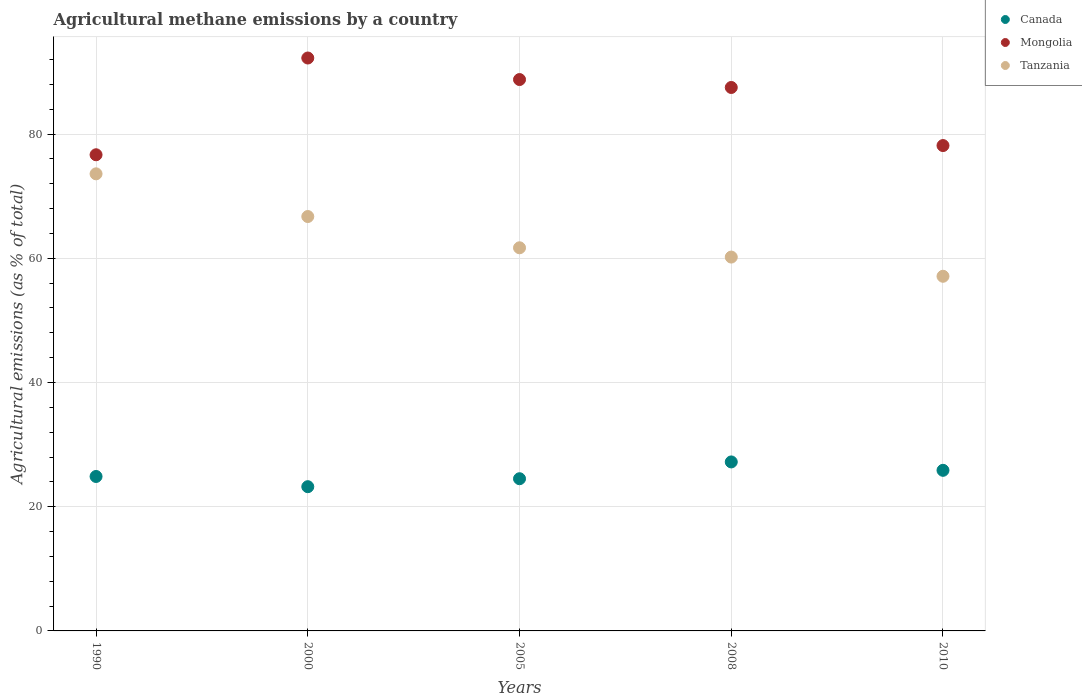What is the amount of agricultural methane emitted in Mongolia in 1990?
Give a very brief answer. 76.66. Across all years, what is the maximum amount of agricultural methane emitted in Canada?
Offer a very short reply. 27.21. Across all years, what is the minimum amount of agricultural methane emitted in Canada?
Provide a short and direct response. 23.22. What is the total amount of agricultural methane emitted in Mongolia in the graph?
Ensure brevity in your answer.  423.3. What is the difference between the amount of agricultural methane emitted in Tanzania in 1990 and that in 2005?
Your answer should be compact. 11.91. What is the difference between the amount of agricultural methane emitted in Tanzania in 1990 and the amount of agricultural methane emitted in Canada in 2010?
Your answer should be very brief. 47.73. What is the average amount of agricultural methane emitted in Mongolia per year?
Offer a terse response. 84.66. In the year 2000, what is the difference between the amount of agricultural methane emitted in Canada and amount of agricultural methane emitted in Mongolia?
Keep it short and to the point. -69.02. What is the ratio of the amount of agricultural methane emitted in Tanzania in 2005 to that in 2008?
Your response must be concise. 1.02. What is the difference between the highest and the second highest amount of agricultural methane emitted in Tanzania?
Offer a terse response. 6.87. What is the difference between the highest and the lowest amount of agricultural methane emitted in Canada?
Provide a succinct answer. 3.99. Is it the case that in every year, the sum of the amount of agricultural methane emitted in Canada and amount of agricultural methane emitted in Mongolia  is greater than the amount of agricultural methane emitted in Tanzania?
Offer a terse response. Yes. Is the amount of agricultural methane emitted in Canada strictly less than the amount of agricultural methane emitted in Tanzania over the years?
Provide a succinct answer. Yes. How many years are there in the graph?
Make the answer very short. 5. What is the difference between two consecutive major ticks on the Y-axis?
Make the answer very short. 20. Does the graph contain any zero values?
Provide a short and direct response. No. Does the graph contain grids?
Keep it short and to the point. Yes. What is the title of the graph?
Your answer should be compact. Agricultural methane emissions by a country. What is the label or title of the X-axis?
Offer a very short reply. Years. What is the label or title of the Y-axis?
Your answer should be compact. Agricultural emissions (as % of total). What is the Agricultural emissions (as % of total) in Canada in 1990?
Provide a succinct answer. 24.86. What is the Agricultural emissions (as % of total) of Mongolia in 1990?
Provide a short and direct response. 76.66. What is the Agricultural emissions (as % of total) of Tanzania in 1990?
Ensure brevity in your answer.  73.59. What is the Agricultural emissions (as % of total) in Canada in 2000?
Ensure brevity in your answer.  23.22. What is the Agricultural emissions (as % of total) in Mongolia in 2000?
Make the answer very short. 92.24. What is the Agricultural emissions (as % of total) of Tanzania in 2000?
Your answer should be very brief. 66.72. What is the Agricultural emissions (as % of total) of Canada in 2005?
Offer a very short reply. 24.5. What is the Agricultural emissions (as % of total) of Mongolia in 2005?
Make the answer very short. 88.77. What is the Agricultural emissions (as % of total) of Tanzania in 2005?
Your answer should be compact. 61.68. What is the Agricultural emissions (as % of total) of Canada in 2008?
Your response must be concise. 27.21. What is the Agricultural emissions (as % of total) of Mongolia in 2008?
Offer a terse response. 87.49. What is the Agricultural emissions (as % of total) of Tanzania in 2008?
Offer a terse response. 60.19. What is the Agricultural emissions (as % of total) of Canada in 2010?
Offer a terse response. 25.86. What is the Agricultural emissions (as % of total) of Mongolia in 2010?
Your response must be concise. 78.14. What is the Agricultural emissions (as % of total) of Tanzania in 2010?
Your response must be concise. 57.1. Across all years, what is the maximum Agricultural emissions (as % of total) in Canada?
Your response must be concise. 27.21. Across all years, what is the maximum Agricultural emissions (as % of total) of Mongolia?
Keep it short and to the point. 92.24. Across all years, what is the maximum Agricultural emissions (as % of total) of Tanzania?
Provide a succinct answer. 73.59. Across all years, what is the minimum Agricultural emissions (as % of total) in Canada?
Give a very brief answer. 23.22. Across all years, what is the minimum Agricultural emissions (as % of total) in Mongolia?
Provide a succinct answer. 76.66. Across all years, what is the minimum Agricultural emissions (as % of total) of Tanzania?
Provide a short and direct response. 57.1. What is the total Agricultural emissions (as % of total) of Canada in the graph?
Your response must be concise. 125.65. What is the total Agricultural emissions (as % of total) in Mongolia in the graph?
Offer a terse response. 423.3. What is the total Agricultural emissions (as % of total) of Tanzania in the graph?
Your answer should be very brief. 319.27. What is the difference between the Agricultural emissions (as % of total) of Canada in 1990 and that in 2000?
Your answer should be compact. 1.64. What is the difference between the Agricultural emissions (as % of total) in Mongolia in 1990 and that in 2000?
Offer a terse response. -15.58. What is the difference between the Agricultural emissions (as % of total) in Tanzania in 1990 and that in 2000?
Give a very brief answer. 6.87. What is the difference between the Agricultural emissions (as % of total) of Canada in 1990 and that in 2005?
Offer a very short reply. 0.36. What is the difference between the Agricultural emissions (as % of total) in Mongolia in 1990 and that in 2005?
Give a very brief answer. -12.11. What is the difference between the Agricultural emissions (as % of total) in Tanzania in 1990 and that in 2005?
Make the answer very short. 11.91. What is the difference between the Agricultural emissions (as % of total) in Canada in 1990 and that in 2008?
Keep it short and to the point. -2.34. What is the difference between the Agricultural emissions (as % of total) in Mongolia in 1990 and that in 2008?
Your answer should be very brief. -10.83. What is the difference between the Agricultural emissions (as % of total) of Tanzania in 1990 and that in 2008?
Keep it short and to the point. 13.4. What is the difference between the Agricultural emissions (as % of total) of Canada in 1990 and that in 2010?
Your answer should be very brief. -0.99. What is the difference between the Agricultural emissions (as % of total) of Mongolia in 1990 and that in 2010?
Offer a terse response. -1.48. What is the difference between the Agricultural emissions (as % of total) in Tanzania in 1990 and that in 2010?
Offer a very short reply. 16.49. What is the difference between the Agricultural emissions (as % of total) in Canada in 2000 and that in 2005?
Provide a short and direct response. -1.28. What is the difference between the Agricultural emissions (as % of total) of Mongolia in 2000 and that in 2005?
Your response must be concise. 3.47. What is the difference between the Agricultural emissions (as % of total) of Tanzania in 2000 and that in 2005?
Offer a terse response. 5.03. What is the difference between the Agricultural emissions (as % of total) in Canada in 2000 and that in 2008?
Your response must be concise. -3.99. What is the difference between the Agricultural emissions (as % of total) in Mongolia in 2000 and that in 2008?
Ensure brevity in your answer.  4.74. What is the difference between the Agricultural emissions (as % of total) in Tanzania in 2000 and that in 2008?
Your response must be concise. 6.53. What is the difference between the Agricultural emissions (as % of total) of Canada in 2000 and that in 2010?
Your answer should be very brief. -2.63. What is the difference between the Agricultural emissions (as % of total) in Mongolia in 2000 and that in 2010?
Your answer should be very brief. 14.1. What is the difference between the Agricultural emissions (as % of total) in Tanzania in 2000 and that in 2010?
Your answer should be very brief. 9.62. What is the difference between the Agricultural emissions (as % of total) of Canada in 2005 and that in 2008?
Keep it short and to the point. -2.7. What is the difference between the Agricultural emissions (as % of total) of Mongolia in 2005 and that in 2008?
Make the answer very short. 1.28. What is the difference between the Agricultural emissions (as % of total) of Tanzania in 2005 and that in 2008?
Your response must be concise. 1.49. What is the difference between the Agricultural emissions (as % of total) in Canada in 2005 and that in 2010?
Provide a succinct answer. -1.35. What is the difference between the Agricultural emissions (as % of total) in Mongolia in 2005 and that in 2010?
Provide a short and direct response. 10.63. What is the difference between the Agricultural emissions (as % of total) of Tanzania in 2005 and that in 2010?
Give a very brief answer. 4.59. What is the difference between the Agricultural emissions (as % of total) of Canada in 2008 and that in 2010?
Ensure brevity in your answer.  1.35. What is the difference between the Agricultural emissions (as % of total) in Mongolia in 2008 and that in 2010?
Your response must be concise. 9.35. What is the difference between the Agricultural emissions (as % of total) of Tanzania in 2008 and that in 2010?
Make the answer very short. 3.09. What is the difference between the Agricultural emissions (as % of total) of Canada in 1990 and the Agricultural emissions (as % of total) of Mongolia in 2000?
Make the answer very short. -67.37. What is the difference between the Agricultural emissions (as % of total) of Canada in 1990 and the Agricultural emissions (as % of total) of Tanzania in 2000?
Offer a terse response. -41.85. What is the difference between the Agricultural emissions (as % of total) of Mongolia in 1990 and the Agricultural emissions (as % of total) of Tanzania in 2000?
Provide a succinct answer. 9.94. What is the difference between the Agricultural emissions (as % of total) of Canada in 1990 and the Agricultural emissions (as % of total) of Mongolia in 2005?
Offer a very short reply. -63.9. What is the difference between the Agricultural emissions (as % of total) in Canada in 1990 and the Agricultural emissions (as % of total) in Tanzania in 2005?
Your response must be concise. -36.82. What is the difference between the Agricultural emissions (as % of total) in Mongolia in 1990 and the Agricultural emissions (as % of total) in Tanzania in 2005?
Ensure brevity in your answer.  14.98. What is the difference between the Agricultural emissions (as % of total) in Canada in 1990 and the Agricultural emissions (as % of total) in Mongolia in 2008?
Your answer should be very brief. -62.63. What is the difference between the Agricultural emissions (as % of total) in Canada in 1990 and the Agricultural emissions (as % of total) in Tanzania in 2008?
Ensure brevity in your answer.  -35.32. What is the difference between the Agricultural emissions (as % of total) of Mongolia in 1990 and the Agricultural emissions (as % of total) of Tanzania in 2008?
Ensure brevity in your answer.  16.47. What is the difference between the Agricultural emissions (as % of total) of Canada in 1990 and the Agricultural emissions (as % of total) of Mongolia in 2010?
Give a very brief answer. -53.28. What is the difference between the Agricultural emissions (as % of total) in Canada in 1990 and the Agricultural emissions (as % of total) in Tanzania in 2010?
Give a very brief answer. -32.23. What is the difference between the Agricultural emissions (as % of total) of Mongolia in 1990 and the Agricultural emissions (as % of total) of Tanzania in 2010?
Your answer should be very brief. 19.56. What is the difference between the Agricultural emissions (as % of total) in Canada in 2000 and the Agricultural emissions (as % of total) in Mongolia in 2005?
Ensure brevity in your answer.  -65.55. What is the difference between the Agricultural emissions (as % of total) of Canada in 2000 and the Agricultural emissions (as % of total) of Tanzania in 2005?
Give a very brief answer. -38.46. What is the difference between the Agricultural emissions (as % of total) of Mongolia in 2000 and the Agricultural emissions (as % of total) of Tanzania in 2005?
Offer a terse response. 30.55. What is the difference between the Agricultural emissions (as % of total) in Canada in 2000 and the Agricultural emissions (as % of total) in Mongolia in 2008?
Keep it short and to the point. -64.27. What is the difference between the Agricultural emissions (as % of total) of Canada in 2000 and the Agricultural emissions (as % of total) of Tanzania in 2008?
Offer a very short reply. -36.97. What is the difference between the Agricultural emissions (as % of total) in Mongolia in 2000 and the Agricultural emissions (as % of total) in Tanzania in 2008?
Ensure brevity in your answer.  32.05. What is the difference between the Agricultural emissions (as % of total) of Canada in 2000 and the Agricultural emissions (as % of total) of Mongolia in 2010?
Your answer should be very brief. -54.92. What is the difference between the Agricultural emissions (as % of total) in Canada in 2000 and the Agricultural emissions (as % of total) in Tanzania in 2010?
Offer a very short reply. -33.88. What is the difference between the Agricultural emissions (as % of total) in Mongolia in 2000 and the Agricultural emissions (as % of total) in Tanzania in 2010?
Ensure brevity in your answer.  35.14. What is the difference between the Agricultural emissions (as % of total) of Canada in 2005 and the Agricultural emissions (as % of total) of Mongolia in 2008?
Your answer should be very brief. -62.99. What is the difference between the Agricultural emissions (as % of total) in Canada in 2005 and the Agricultural emissions (as % of total) in Tanzania in 2008?
Your answer should be very brief. -35.69. What is the difference between the Agricultural emissions (as % of total) in Mongolia in 2005 and the Agricultural emissions (as % of total) in Tanzania in 2008?
Ensure brevity in your answer.  28.58. What is the difference between the Agricultural emissions (as % of total) of Canada in 2005 and the Agricultural emissions (as % of total) of Mongolia in 2010?
Offer a terse response. -53.64. What is the difference between the Agricultural emissions (as % of total) of Canada in 2005 and the Agricultural emissions (as % of total) of Tanzania in 2010?
Give a very brief answer. -32.59. What is the difference between the Agricultural emissions (as % of total) in Mongolia in 2005 and the Agricultural emissions (as % of total) in Tanzania in 2010?
Your response must be concise. 31.67. What is the difference between the Agricultural emissions (as % of total) in Canada in 2008 and the Agricultural emissions (as % of total) in Mongolia in 2010?
Provide a short and direct response. -50.93. What is the difference between the Agricultural emissions (as % of total) of Canada in 2008 and the Agricultural emissions (as % of total) of Tanzania in 2010?
Provide a succinct answer. -29.89. What is the difference between the Agricultural emissions (as % of total) in Mongolia in 2008 and the Agricultural emissions (as % of total) in Tanzania in 2010?
Offer a very short reply. 30.4. What is the average Agricultural emissions (as % of total) in Canada per year?
Offer a terse response. 25.13. What is the average Agricultural emissions (as % of total) in Mongolia per year?
Offer a very short reply. 84.66. What is the average Agricultural emissions (as % of total) of Tanzania per year?
Keep it short and to the point. 63.85. In the year 1990, what is the difference between the Agricultural emissions (as % of total) of Canada and Agricultural emissions (as % of total) of Mongolia?
Provide a succinct answer. -51.79. In the year 1990, what is the difference between the Agricultural emissions (as % of total) in Canada and Agricultural emissions (as % of total) in Tanzania?
Your response must be concise. -48.72. In the year 1990, what is the difference between the Agricultural emissions (as % of total) of Mongolia and Agricultural emissions (as % of total) of Tanzania?
Your answer should be compact. 3.07. In the year 2000, what is the difference between the Agricultural emissions (as % of total) of Canada and Agricultural emissions (as % of total) of Mongolia?
Provide a short and direct response. -69.02. In the year 2000, what is the difference between the Agricultural emissions (as % of total) of Canada and Agricultural emissions (as % of total) of Tanzania?
Your answer should be compact. -43.49. In the year 2000, what is the difference between the Agricultural emissions (as % of total) of Mongolia and Agricultural emissions (as % of total) of Tanzania?
Make the answer very short. 25.52. In the year 2005, what is the difference between the Agricultural emissions (as % of total) of Canada and Agricultural emissions (as % of total) of Mongolia?
Your response must be concise. -64.27. In the year 2005, what is the difference between the Agricultural emissions (as % of total) of Canada and Agricultural emissions (as % of total) of Tanzania?
Your answer should be very brief. -37.18. In the year 2005, what is the difference between the Agricultural emissions (as % of total) in Mongolia and Agricultural emissions (as % of total) in Tanzania?
Your response must be concise. 27.09. In the year 2008, what is the difference between the Agricultural emissions (as % of total) of Canada and Agricultural emissions (as % of total) of Mongolia?
Make the answer very short. -60.29. In the year 2008, what is the difference between the Agricultural emissions (as % of total) in Canada and Agricultural emissions (as % of total) in Tanzania?
Give a very brief answer. -32.98. In the year 2008, what is the difference between the Agricultural emissions (as % of total) in Mongolia and Agricultural emissions (as % of total) in Tanzania?
Your response must be concise. 27.3. In the year 2010, what is the difference between the Agricultural emissions (as % of total) in Canada and Agricultural emissions (as % of total) in Mongolia?
Your answer should be very brief. -52.29. In the year 2010, what is the difference between the Agricultural emissions (as % of total) in Canada and Agricultural emissions (as % of total) in Tanzania?
Keep it short and to the point. -31.24. In the year 2010, what is the difference between the Agricultural emissions (as % of total) in Mongolia and Agricultural emissions (as % of total) in Tanzania?
Offer a terse response. 21.04. What is the ratio of the Agricultural emissions (as % of total) in Canada in 1990 to that in 2000?
Offer a very short reply. 1.07. What is the ratio of the Agricultural emissions (as % of total) in Mongolia in 1990 to that in 2000?
Provide a succinct answer. 0.83. What is the ratio of the Agricultural emissions (as % of total) in Tanzania in 1990 to that in 2000?
Give a very brief answer. 1.1. What is the ratio of the Agricultural emissions (as % of total) in Canada in 1990 to that in 2005?
Your answer should be compact. 1.01. What is the ratio of the Agricultural emissions (as % of total) in Mongolia in 1990 to that in 2005?
Your answer should be very brief. 0.86. What is the ratio of the Agricultural emissions (as % of total) of Tanzania in 1990 to that in 2005?
Provide a succinct answer. 1.19. What is the ratio of the Agricultural emissions (as % of total) in Canada in 1990 to that in 2008?
Offer a very short reply. 0.91. What is the ratio of the Agricultural emissions (as % of total) of Mongolia in 1990 to that in 2008?
Your answer should be very brief. 0.88. What is the ratio of the Agricultural emissions (as % of total) of Tanzania in 1990 to that in 2008?
Your answer should be very brief. 1.22. What is the ratio of the Agricultural emissions (as % of total) in Canada in 1990 to that in 2010?
Offer a terse response. 0.96. What is the ratio of the Agricultural emissions (as % of total) in Tanzania in 1990 to that in 2010?
Give a very brief answer. 1.29. What is the ratio of the Agricultural emissions (as % of total) of Canada in 2000 to that in 2005?
Make the answer very short. 0.95. What is the ratio of the Agricultural emissions (as % of total) in Mongolia in 2000 to that in 2005?
Your answer should be very brief. 1.04. What is the ratio of the Agricultural emissions (as % of total) in Tanzania in 2000 to that in 2005?
Provide a short and direct response. 1.08. What is the ratio of the Agricultural emissions (as % of total) of Canada in 2000 to that in 2008?
Your answer should be compact. 0.85. What is the ratio of the Agricultural emissions (as % of total) of Mongolia in 2000 to that in 2008?
Offer a terse response. 1.05. What is the ratio of the Agricultural emissions (as % of total) in Tanzania in 2000 to that in 2008?
Your response must be concise. 1.11. What is the ratio of the Agricultural emissions (as % of total) of Canada in 2000 to that in 2010?
Offer a very short reply. 0.9. What is the ratio of the Agricultural emissions (as % of total) in Mongolia in 2000 to that in 2010?
Your response must be concise. 1.18. What is the ratio of the Agricultural emissions (as % of total) of Tanzania in 2000 to that in 2010?
Provide a short and direct response. 1.17. What is the ratio of the Agricultural emissions (as % of total) in Canada in 2005 to that in 2008?
Offer a very short reply. 0.9. What is the ratio of the Agricultural emissions (as % of total) in Mongolia in 2005 to that in 2008?
Make the answer very short. 1.01. What is the ratio of the Agricultural emissions (as % of total) in Tanzania in 2005 to that in 2008?
Give a very brief answer. 1.02. What is the ratio of the Agricultural emissions (as % of total) of Canada in 2005 to that in 2010?
Your answer should be compact. 0.95. What is the ratio of the Agricultural emissions (as % of total) of Mongolia in 2005 to that in 2010?
Your response must be concise. 1.14. What is the ratio of the Agricultural emissions (as % of total) in Tanzania in 2005 to that in 2010?
Provide a short and direct response. 1.08. What is the ratio of the Agricultural emissions (as % of total) in Canada in 2008 to that in 2010?
Your response must be concise. 1.05. What is the ratio of the Agricultural emissions (as % of total) of Mongolia in 2008 to that in 2010?
Ensure brevity in your answer.  1.12. What is the ratio of the Agricultural emissions (as % of total) in Tanzania in 2008 to that in 2010?
Offer a terse response. 1.05. What is the difference between the highest and the second highest Agricultural emissions (as % of total) in Canada?
Your answer should be very brief. 1.35. What is the difference between the highest and the second highest Agricultural emissions (as % of total) of Mongolia?
Keep it short and to the point. 3.47. What is the difference between the highest and the second highest Agricultural emissions (as % of total) of Tanzania?
Provide a short and direct response. 6.87. What is the difference between the highest and the lowest Agricultural emissions (as % of total) of Canada?
Ensure brevity in your answer.  3.99. What is the difference between the highest and the lowest Agricultural emissions (as % of total) in Mongolia?
Your answer should be compact. 15.58. What is the difference between the highest and the lowest Agricultural emissions (as % of total) of Tanzania?
Ensure brevity in your answer.  16.49. 